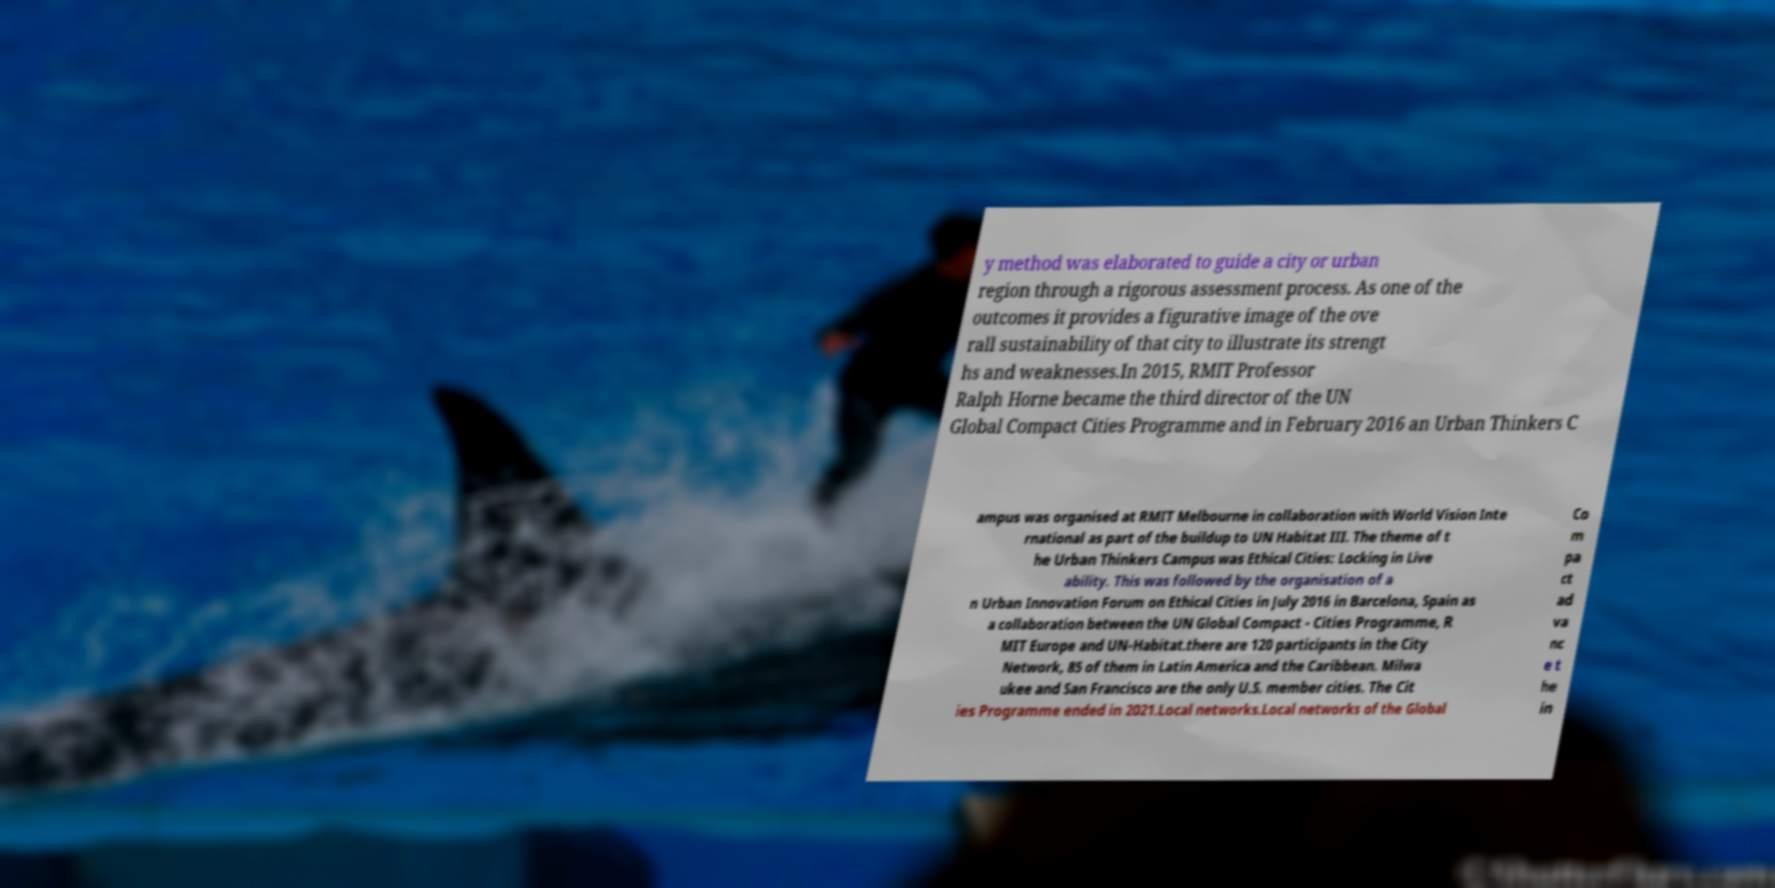Could you extract and type out the text from this image? y method was elaborated to guide a city or urban region through a rigorous assessment process. As one of the outcomes it provides a figurative image of the ove rall sustainability of that city to illustrate its strengt hs and weaknesses.In 2015, RMIT Professor Ralph Horne became the third director of the UN Global Compact Cities Programme and in February 2016 an Urban Thinkers C ampus was organised at RMIT Melbourne in collaboration with World Vision Inte rnational as part of the buildup to UN Habitat III. The theme of t he Urban Thinkers Campus was Ethical Cities: Locking in Live ability. This was followed by the organisation of a n Urban Innovation Forum on Ethical Cities in July 2016 in Barcelona, Spain as a collaboration between the UN Global Compact - Cities Programme, R MIT Europe and UN-Habitat.there are 120 participants in the City Network, 85 of them in Latin America and the Caribbean. Milwa ukee and San Francisco are the only U.S. member cities. The Cit ies Programme ended in 2021.Local networks.Local networks of the Global Co m pa ct ad va nc e t he in 